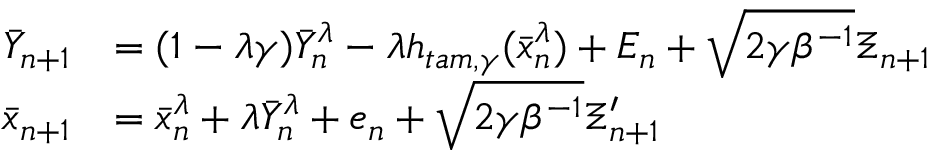<formula> <loc_0><loc_0><loc_500><loc_500>\begin{array} { r l } { \bar { Y } _ { n + 1 } } & { = ( 1 - \lambda \gamma ) \bar { Y } _ { n } ^ { \lambda } - \lambda h _ { t a m , \gamma } ( \bar { x } _ { n } ^ { \lambda } ) + E _ { n } + \sqrt { 2 \gamma \beta ^ { - 1 } } \Xi _ { n + 1 } } \\ { \bar { x } _ { n + 1 } } & { = \bar { x } _ { n } ^ { \lambda } + \lambda \bar { Y } _ { n } ^ { \lambda } + e _ { n } + \sqrt { 2 \gamma \beta ^ { - 1 } } \Xi _ { n + 1 } ^ { \prime } } \end{array}</formula> 